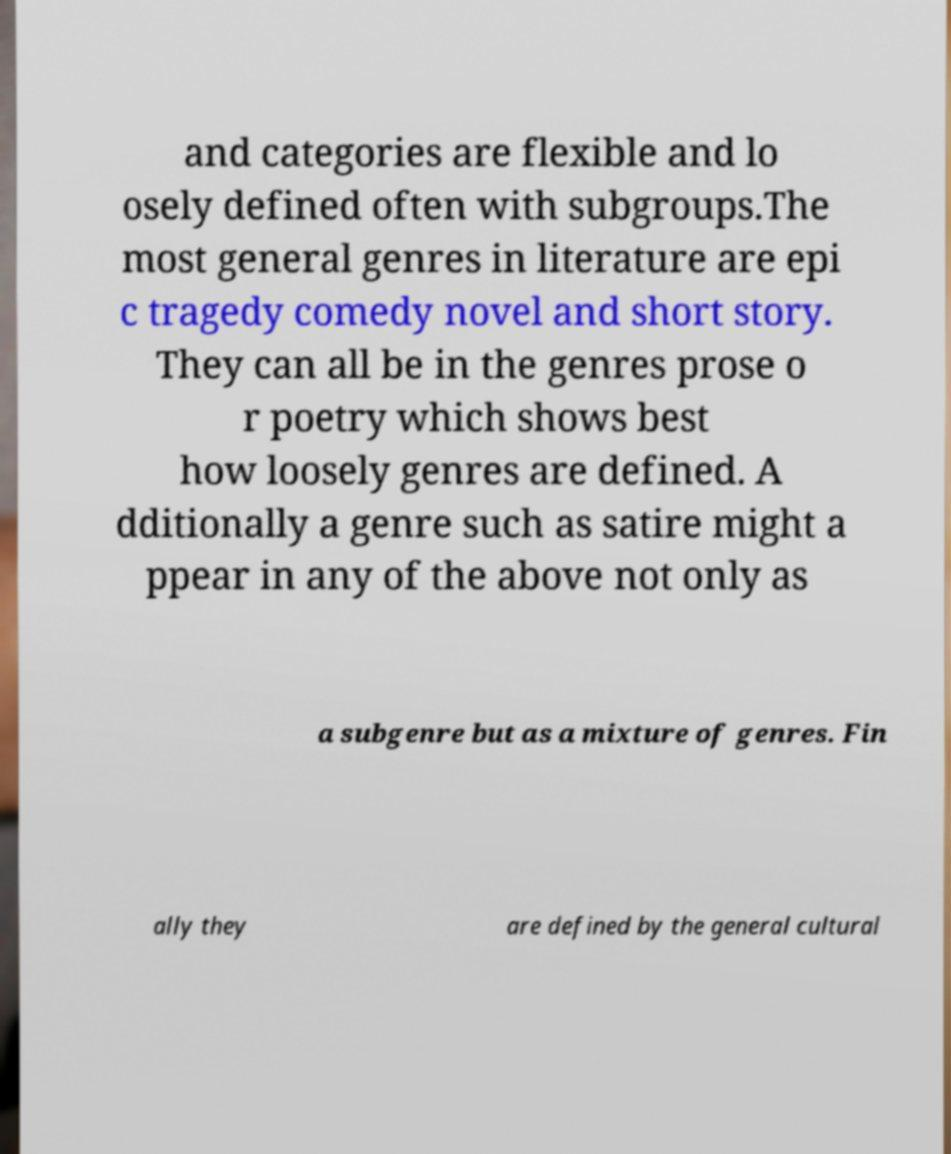Could you assist in decoding the text presented in this image and type it out clearly? and categories are flexible and lo osely defined often with subgroups.The most general genres in literature are epi c tragedy comedy novel and short story. They can all be in the genres prose o r poetry which shows best how loosely genres are defined. A dditionally a genre such as satire might a ppear in any of the above not only as a subgenre but as a mixture of genres. Fin ally they are defined by the general cultural 